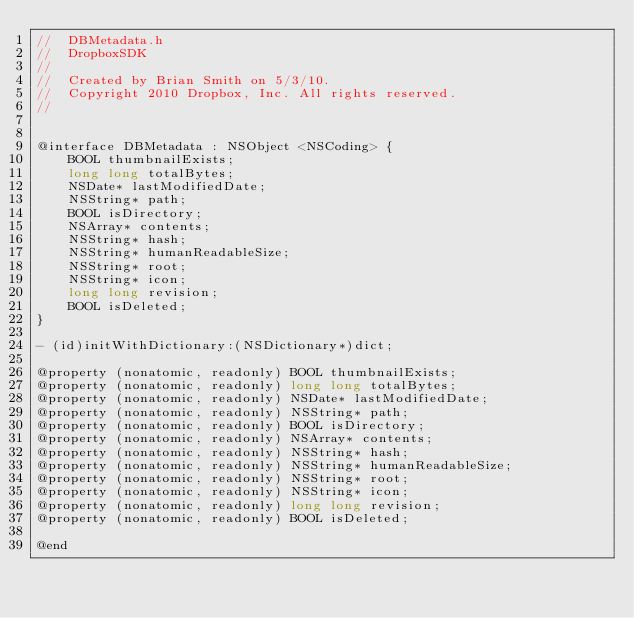<code> <loc_0><loc_0><loc_500><loc_500><_C_>//  DBMetadata.h
//  DropboxSDK
//
//  Created by Brian Smith on 5/3/10.
//  Copyright 2010 Dropbox, Inc. All rights reserved.
//


@interface DBMetadata : NSObject <NSCoding> {
    BOOL thumbnailExists;
    long long totalBytes;
    NSDate* lastModifiedDate;
    NSString* path;
    BOOL isDirectory;
    NSArray* contents;
    NSString* hash;
    NSString* humanReadableSize;
    NSString* root;
    NSString* icon;
    long long revision;
    BOOL isDeleted;
}

- (id)initWithDictionary:(NSDictionary*)dict;

@property (nonatomic, readonly) BOOL thumbnailExists;
@property (nonatomic, readonly) long long totalBytes;
@property (nonatomic, readonly) NSDate* lastModifiedDate;
@property (nonatomic, readonly) NSString* path;
@property (nonatomic, readonly) BOOL isDirectory;
@property (nonatomic, readonly) NSArray* contents;
@property (nonatomic, readonly) NSString* hash;
@property (nonatomic, readonly) NSString* humanReadableSize;
@property (nonatomic, readonly) NSString* root;
@property (nonatomic, readonly) NSString* icon;
@property (nonatomic, readonly) long long revision;
@property (nonatomic, readonly) BOOL isDeleted;

@end
</code> 